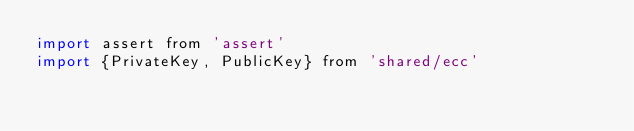<code> <loc_0><loc_0><loc_500><loc_500><_JavaScript_>import assert from 'assert'
import {PrivateKey, PublicKey} from 'shared/ecc'</code> 